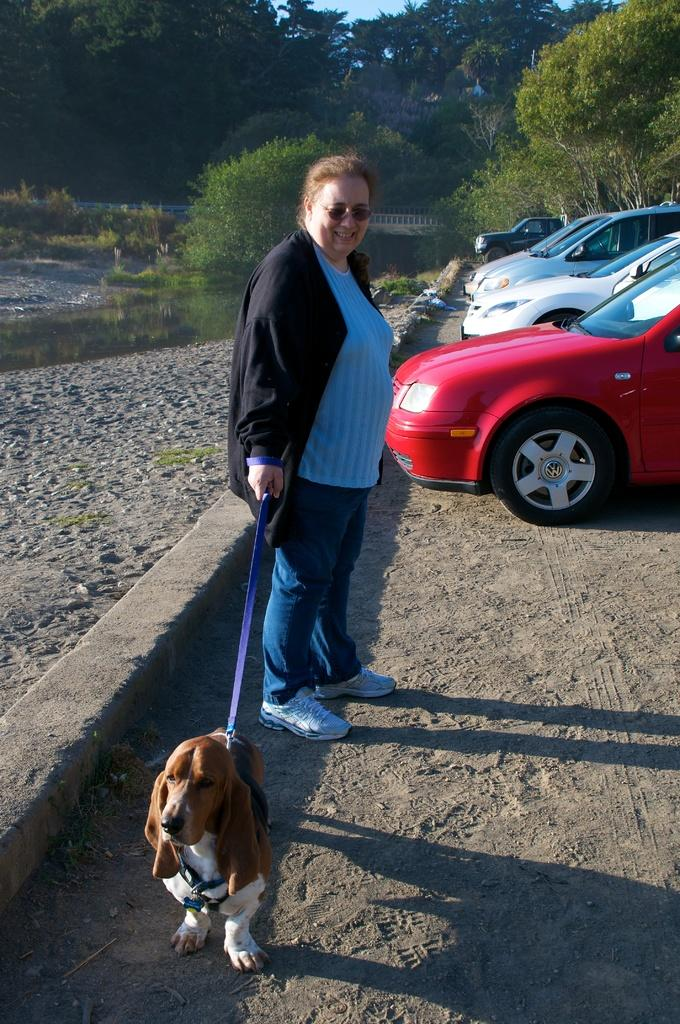What is the main subject of the image? The main subject of the image is a woman. What is the woman doing in the image? The woman is standing and holding a dog. Can you describe the background of the image? There is a vehicle and trees in the background of the image. How far away is the vehicle from the woman? The vehicle is in the background, so it is at a distance from the woman. What news is the actor reading in the image? There is no actor or news present in the image. The image features a woman holding a dog, with a vehicle and trees in the background. 